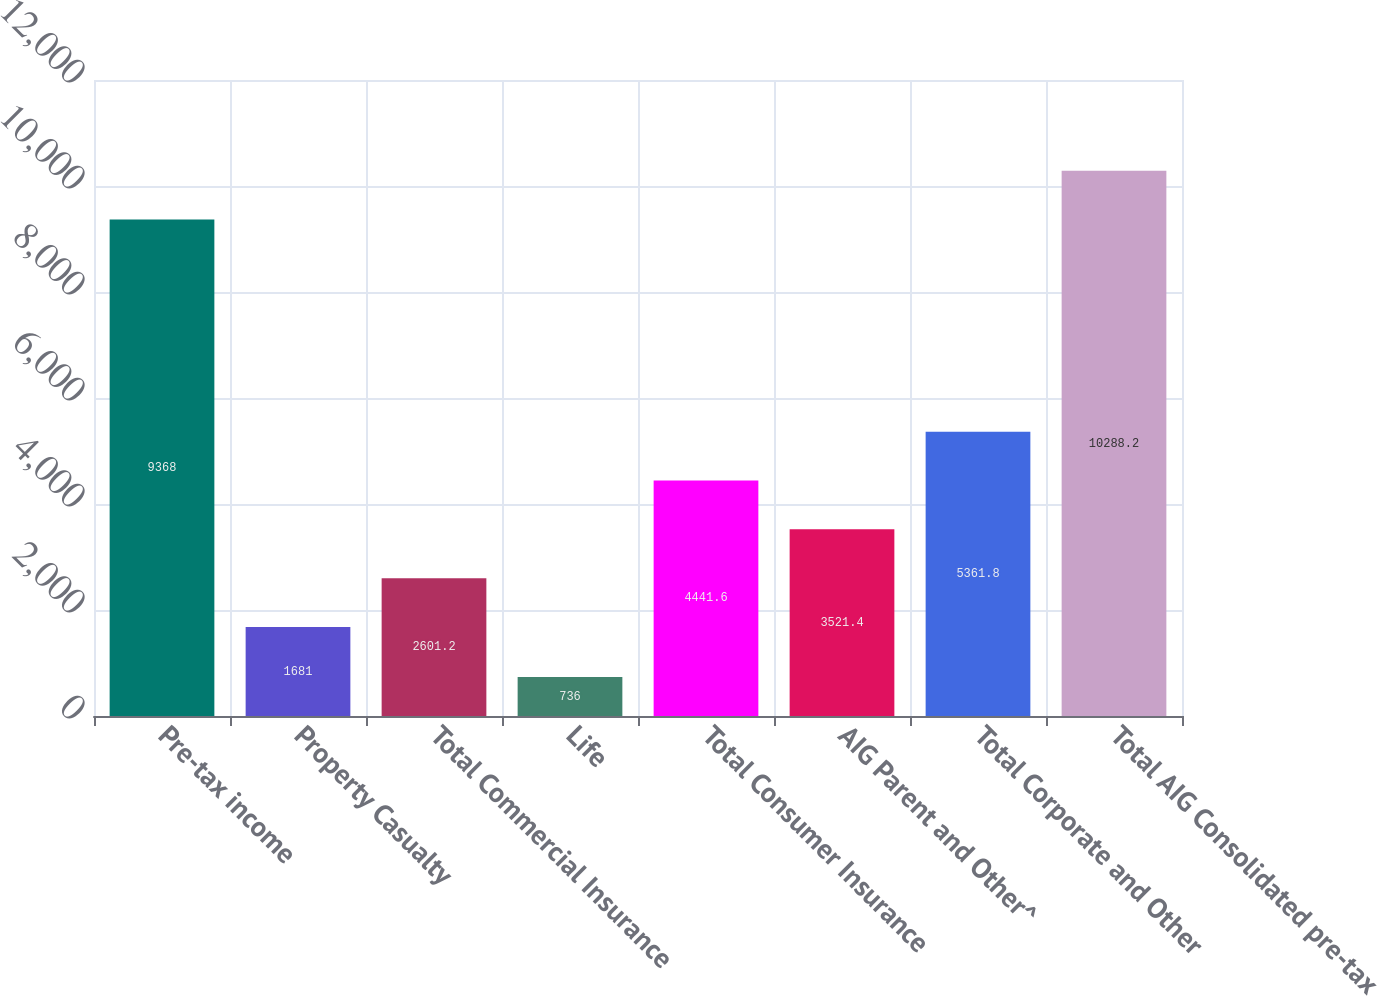Convert chart to OTSL. <chart><loc_0><loc_0><loc_500><loc_500><bar_chart><fcel>Pre-tax income<fcel>Property Casualty<fcel>Total Commercial Insurance<fcel>Life<fcel>Total Consumer Insurance<fcel>AIG Parent and Other^<fcel>Total Corporate and Other<fcel>Total AIG Consolidated pre-tax<nl><fcel>9368<fcel>1681<fcel>2601.2<fcel>736<fcel>4441.6<fcel>3521.4<fcel>5361.8<fcel>10288.2<nl></chart> 